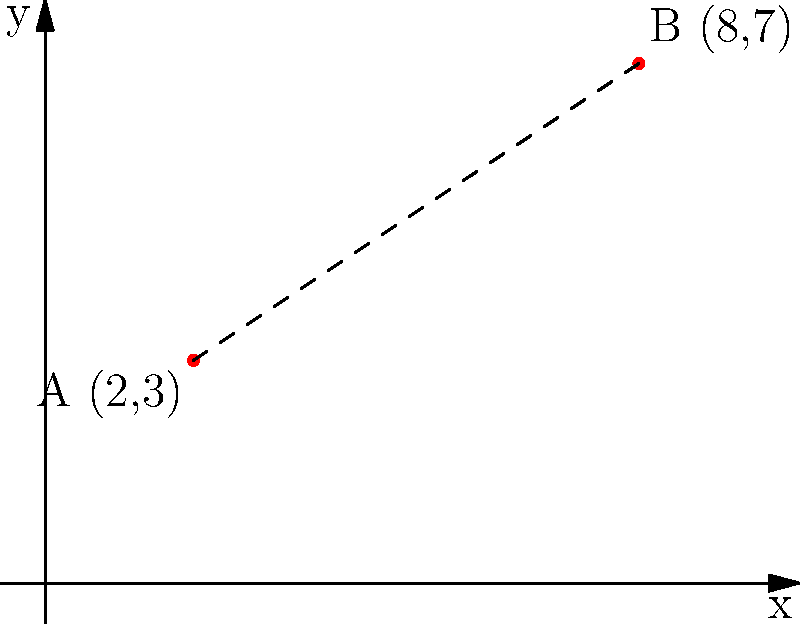At a crime scene, two pieces of evidence are marked on a grid system. Evidence marker A is placed at coordinates (2,3) and evidence marker B is at (8,7). Calculate the distance between these two markers to the nearest tenth of a unit. To find the distance between two points on a coordinate plane, we can use the distance formula, which is derived from the Pythagorean theorem:

$$ d = \sqrt{(x_2 - x_1)^2 + (y_2 - y_1)^2} $$

Where $(x_1, y_1)$ are the coordinates of the first point and $(x_2, y_2)$ are the coordinates of the second point.

Let's plug in our values:
$(x_1, y_1) = (2, 3)$ for point A
$(x_2, y_2) = (8, 7)$ for point B

$$ d = \sqrt{(8 - 2)^2 + (7 - 3)^2} $$

Simplify inside the parentheses:
$$ d = \sqrt{6^2 + 4^2} $$

Calculate the squares:
$$ d = \sqrt{36 + 16} $$

Add under the square root:
$$ d = \sqrt{52} $$

Calculate the square root:
$$ d \approx 7.211 $$

Rounding to the nearest tenth:
$$ d \approx 7.2 $$

Therefore, the distance between the two evidence markers is approximately 7.2 units.
Answer: 7.2 units 